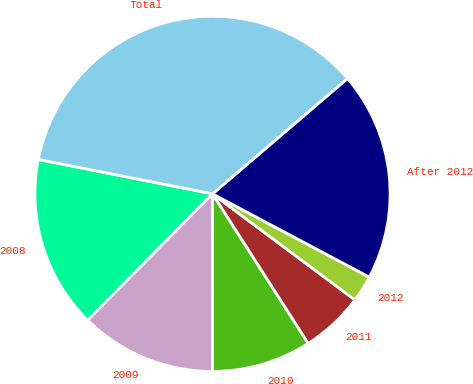Convert chart to OTSL. <chart><loc_0><loc_0><loc_500><loc_500><pie_chart><fcel>2008<fcel>2009<fcel>2010<fcel>2011<fcel>2012<fcel>After 2012<fcel>Total<nl><fcel>15.71%<fcel>12.39%<fcel>9.07%<fcel>5.75%<fcel>2.42%<fcel>19.03%<fcel>35.64%<nl></chart> 